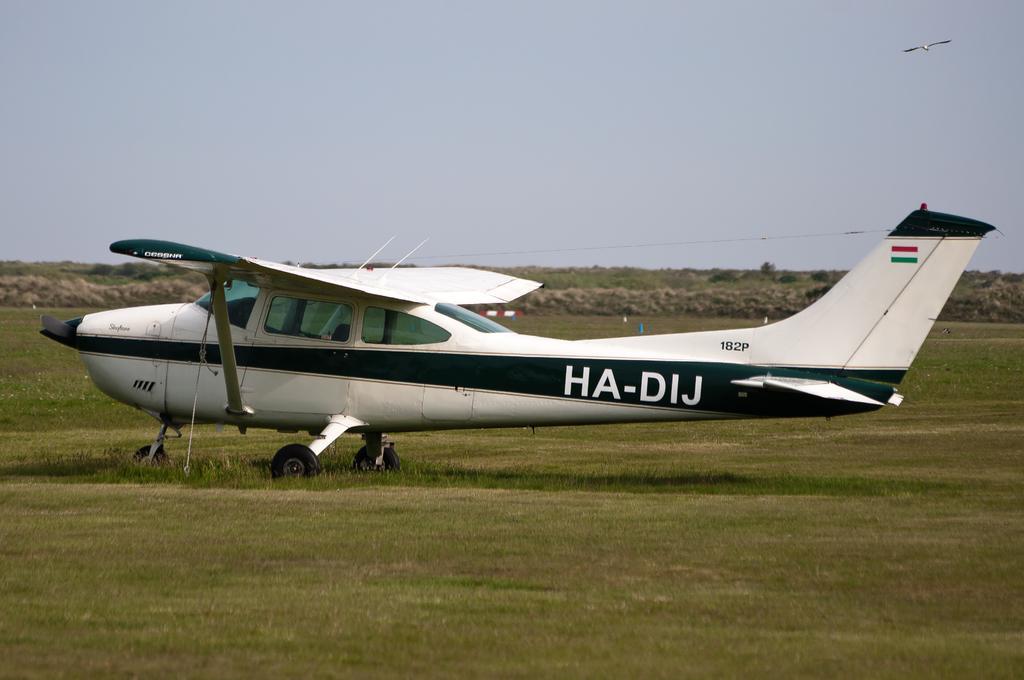Describe this image in one or two sentences. In the center of the image, we can see an aeroplane and in the background, there are hills and we can see some objects on the ground. At the top, there is a bird flying in the sky. 